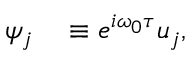<formula> <loc_0><loc_0><loc_500><loc_500>\begin{array} { r l } { \psi _ { j } } & \equiv e ^ { i \omega _ { 0 } \tau } u _ { j } , } \end{array}</formula> 